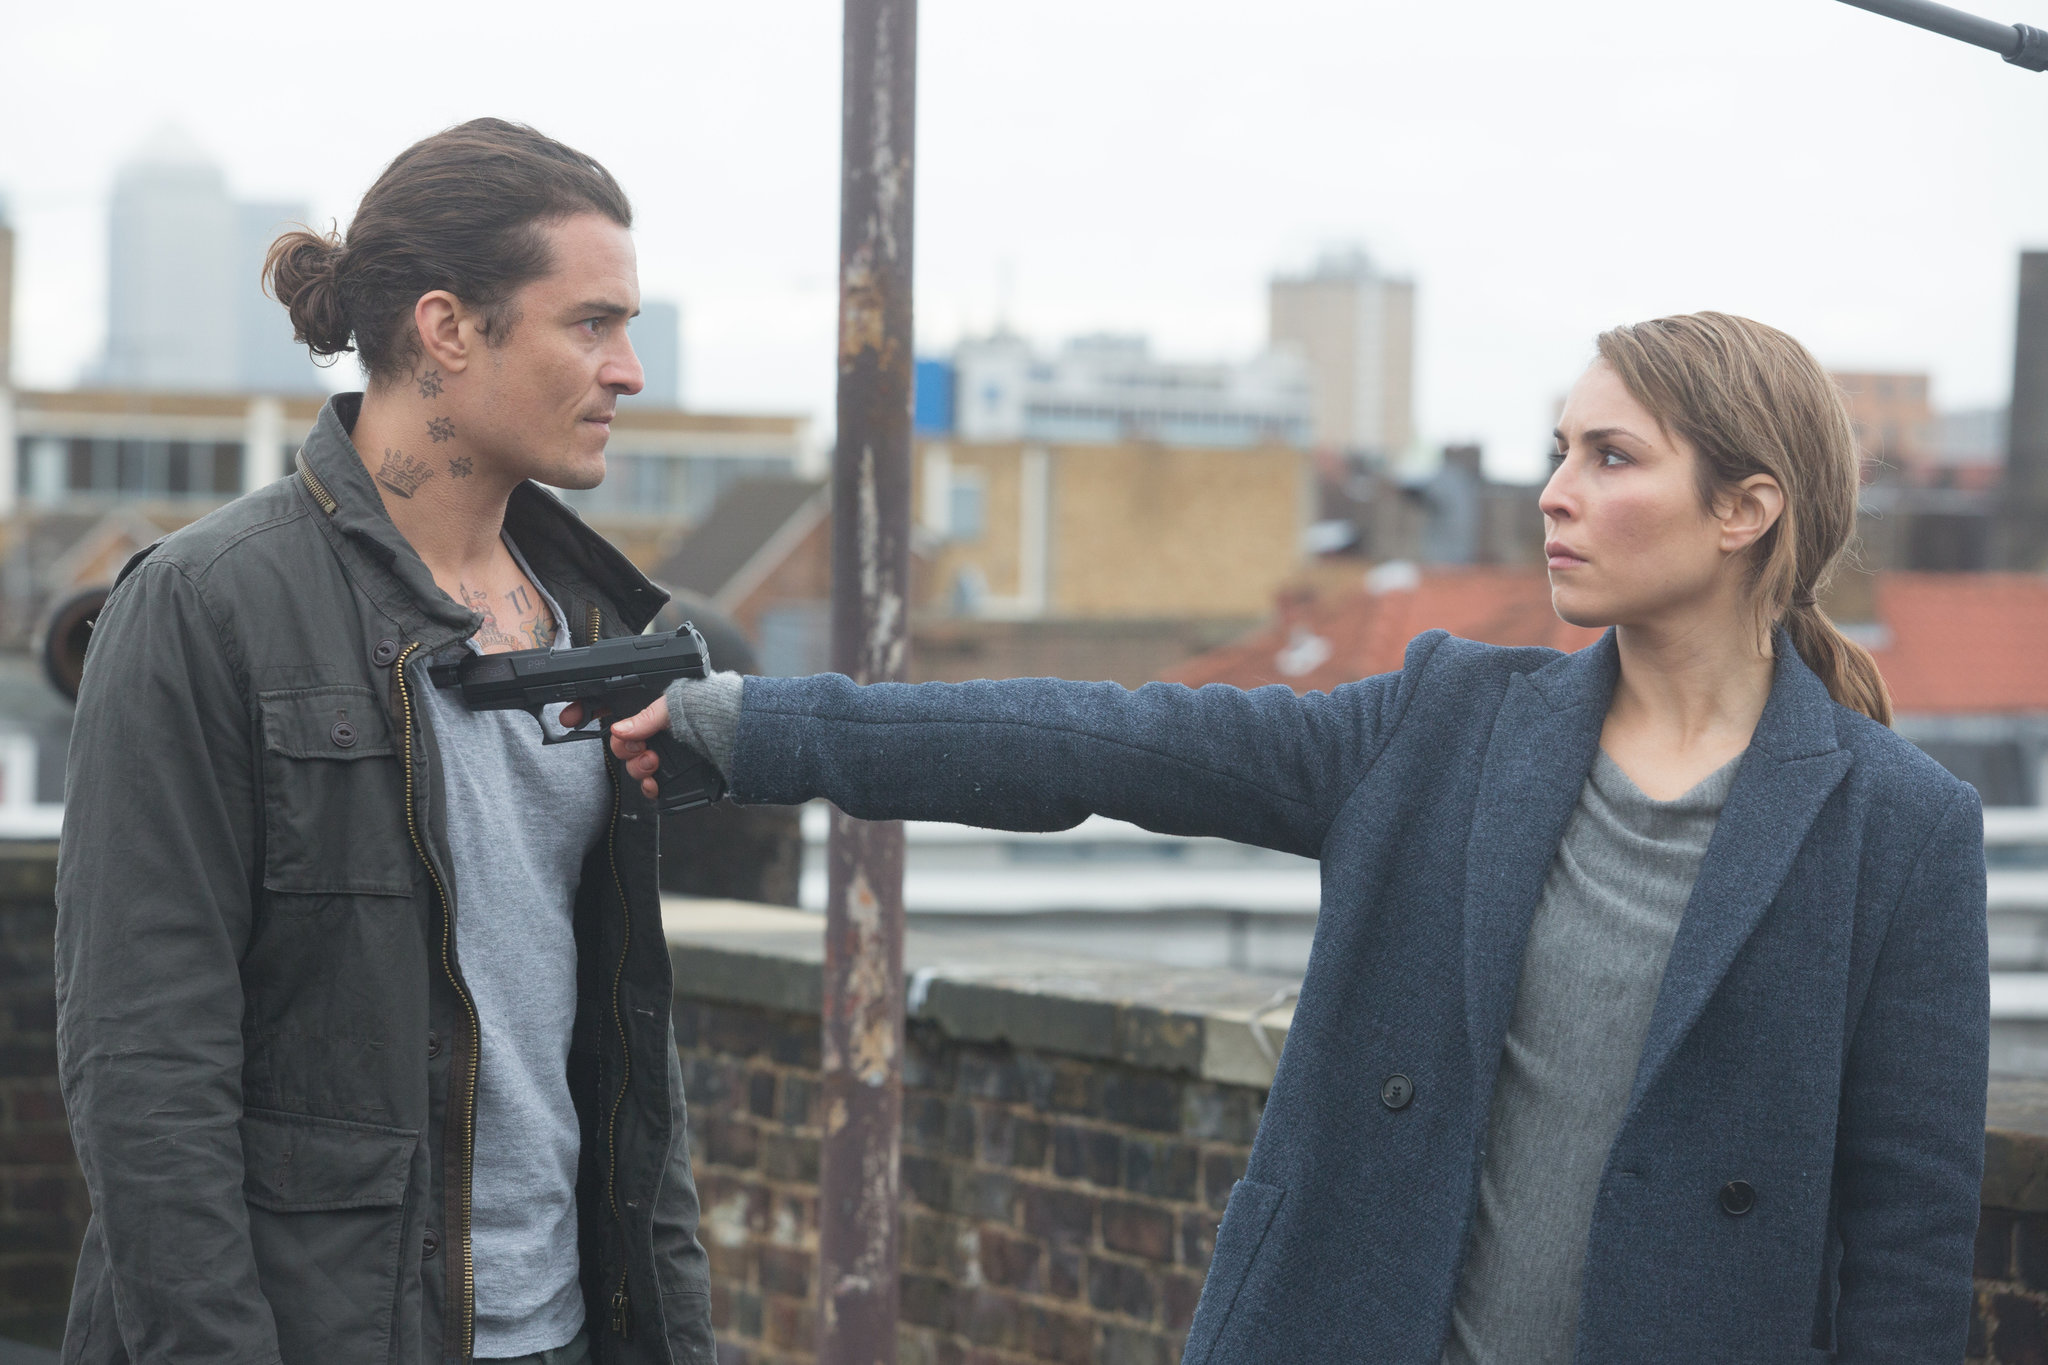If you were to imagine a wild scenario for this image, what would it be? Imagine a fantastical twist: sharegpt4v/sam and the man are not just ordinary humans but members of an ancient guardian race protecting hidden portals to other dimensions. The tattoos on the man's neck are mystical symbols that signify his allegiance to a rival faction intent on controlling these portals for sinister purposes. In this intense rooftop scene, sharegpt4v/sam has finally cornered him, ready to prevent a catastrophe that could tear apart the fabric of reality itself. The city skyline in the background is one of the last remaining strongholds of normalcy, teetering on the brink of interdimensional chaos. Could you describe a realistic and short scenario for this image? In a realistic scenario, this image could depict an undercover cop, sharegpt4v/sam, who has finally tracked down a notorious gang member after a long chase. She's cornered him on the rooftop, extracting a crucial confession or attempting to get information on a larger criminal network while the cityscape behind them symbolizes the broader battle between law enforcement and organized crime. Could you describe a realistic and long scenario for this image? In a more detailed and realistic scenario, sharegpt4v/sam, whose past is marred by tragedy, is a seasoned cop who has been on the trail of a dangerous criminal syndicate for years. The man standing in front of her is a key member of this syndicate, who has evaded capture through cunning and violence. After a cat-and-mouse game that led through various city locales and involved numerous conflicts, she finally corners him on this isolated rooftop. The scene is somber yet packed with tension, as sharegpt4v/sam is not just arresting a criminal but confronting the man responsible for personal suffering and the broader chaos in the city. Here, she seeks justice not only for herself but for countless victims, determined to end his reign of terror. The city skyline behind them, often a place of action and crime, stands silent witness to the culmination of this long-running pursuit. 